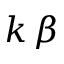Convert formula to latex. <formula><loc_0><loc_0><loc_500><loc_500>k \, \beta</formula> 